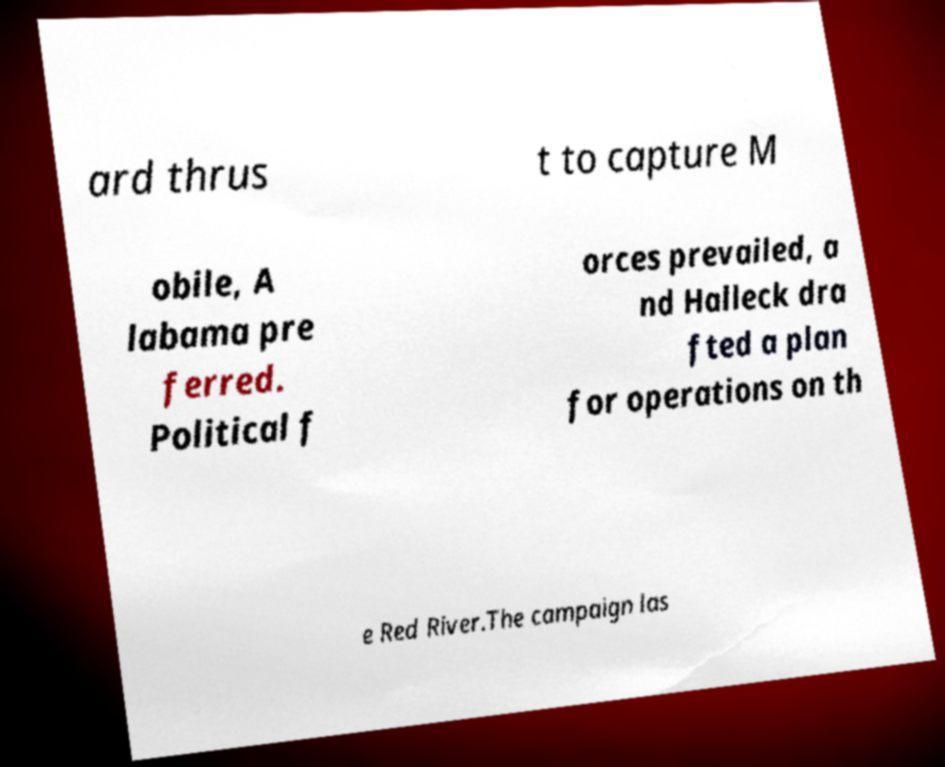Please read and relay the text visible in this image. What does it say? ard thrus t to capture M obile, A labama pre ferred. Political f orces prevailed, a nd Halleck dra fted a plan for operations on th e Red River.The campaign las 